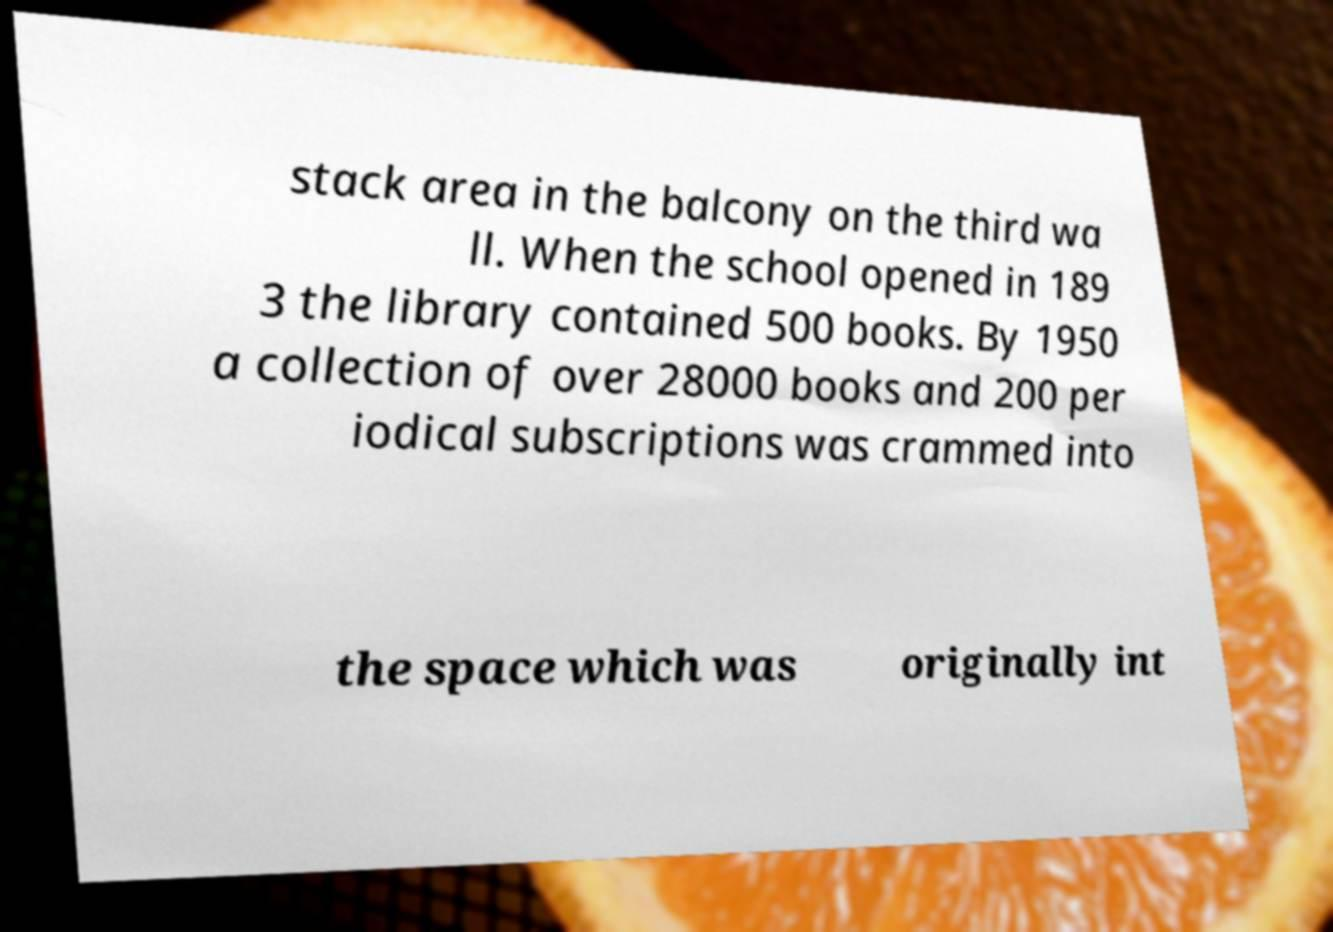Can you read and provide the text displayed in the image?This photo seems to have some interesting text. Can you extract and type it out for me? stack area in the balcony on the third wa ll. When the school opened in 189 3 the library contained 500 books. By 1950 a collection of over 28000 books and 200 per iodical subscriptions was crammed into the space which was originally int 